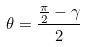Convert formula to latex. <formula><loc_0><loc_0><loc_500><loc_500>\theta = \frac { \frac { \pi } { 2 } - \gamma } { 2 }</formula> 